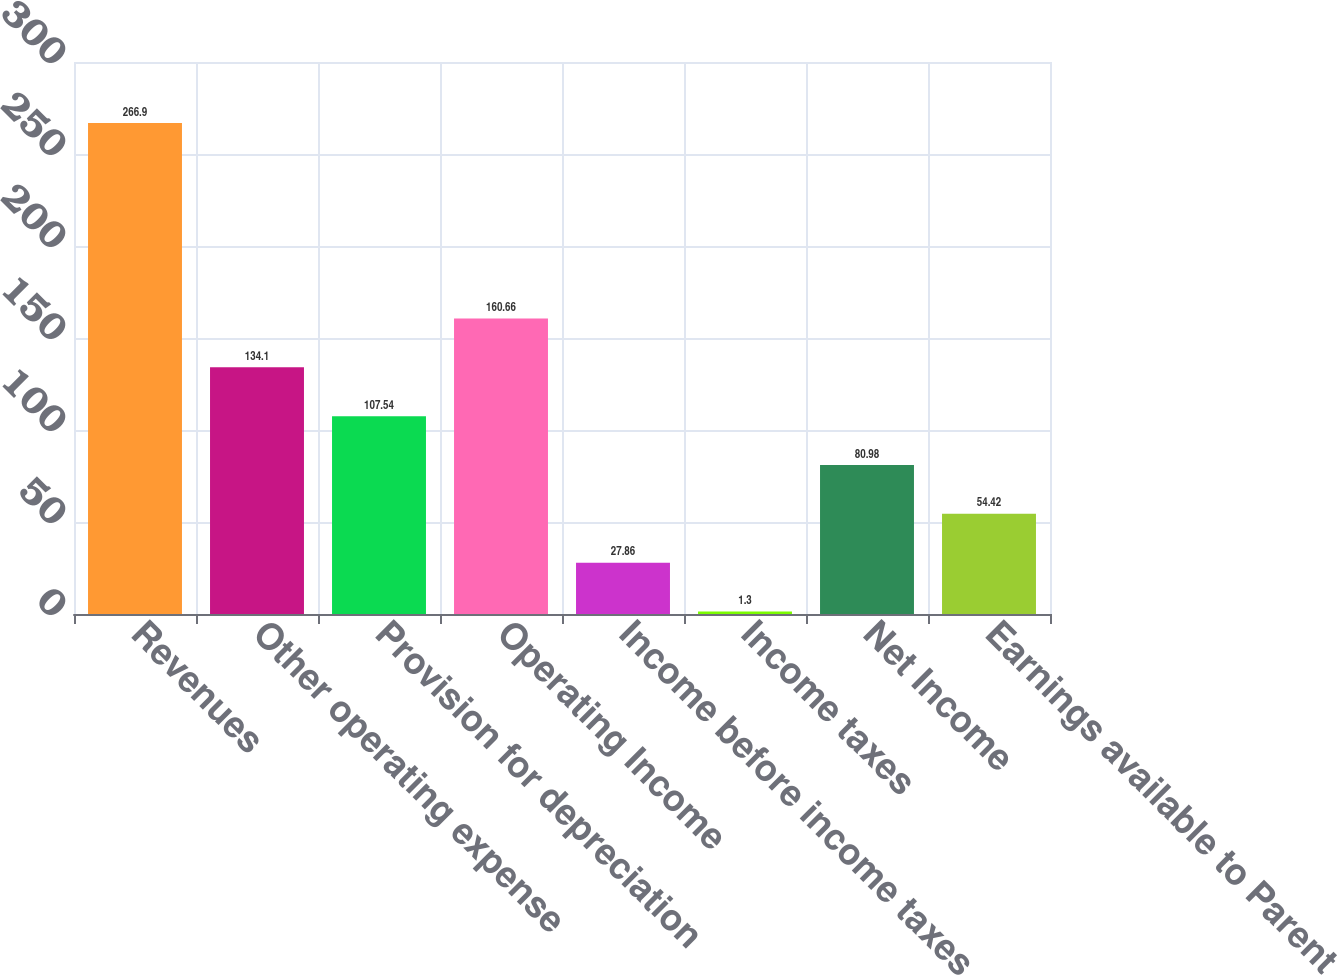Convert chart. <chart><loc_0><loc_0><loc_500><loc_500><bar_chart><fcel>Revenues<fcel>Other operating expense<fcel>Provision for depreciation<fcel>Operating Income<fcel>Income before income taxes<fcel>Income taxes<fcel>Net Income<fcel>Earnings available to Parent<nl><fcel>266.9<fcel>134.1<fcel>107.54<fcel>160.66<fcel>27.86<fcel>1.3<fcel>80.98<fcel>54.42<nl></chart> 